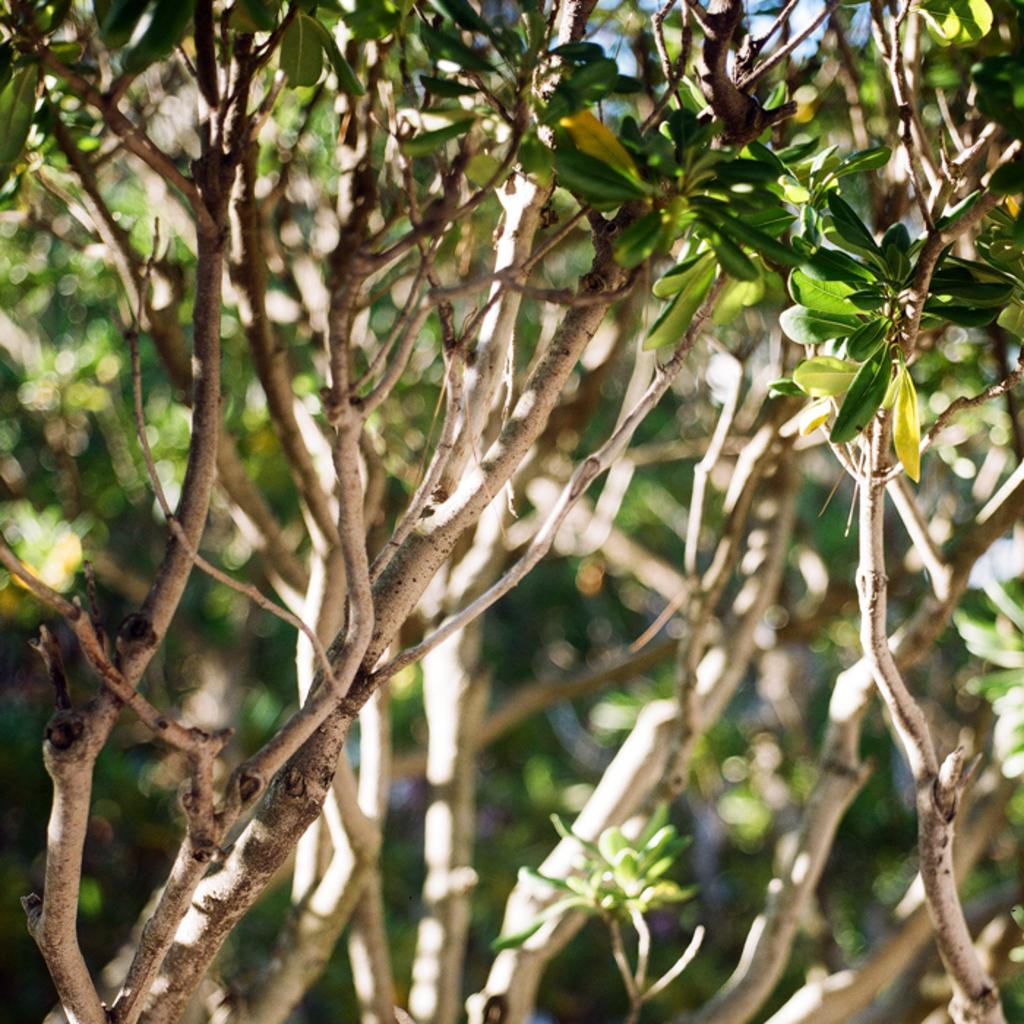What type of vegetation is present in the image? There are trees in the image. What are the main components of the trees? The trees have stems and leaves. What is the weight of the street in the image? There is no street present in the image, so it is not possible to determine its weight. 